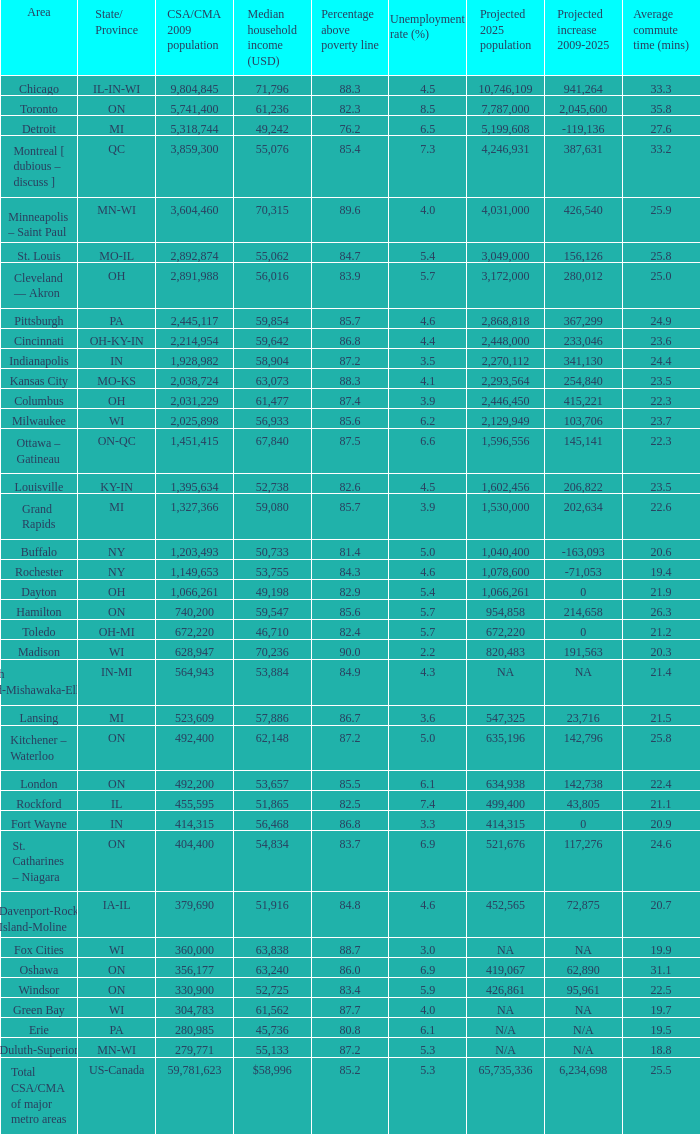What's the CSA/CMA Population in IA-IL? 379690.0. Parse the full table. {'header': ['Area', 'State/ Province', 'CSA/CMA 2009 population', 'Median household income (USD)', 'Percentage above poverty line', 'Unemployment rate (%)', 'Projected 2025 population', 'Projected increase 2009-2025', 'Average commute time (mins)'], 'rows': [['Chicago', 'IL-IN-WI', '9,804,845', '71,796', '88.3', '4.5', '10,746,109', '941,264', '33.3'], ['Toronto', 'ON', '5,741,400', '61,236', '82.3', '8.5', '7,787,000', '2,045,600', '35.8'], ['Detroit', 'MI', '5,318,744', '49,242', '76.2', '6.5', '5,199,608', '-119,136', '27.6'], ['Montreal [ dubious – discuss ]', 'QC', '3,859,300', '55,076', '85.4', '7.3', '4,246,931', '387,631', '33.2'], ['Minneapolis – Saint Paul', 'MN-WI', '3,604,460', '70,315', '89.6', '4.0', '4,031,000', '426,540', '25.9'], ['St. Louis', 'MO-IL', '2,892,874', '55,062', '84.7', '5.4', '3,049,000', '156,126', '25.8'], ['Cleveland — Akron', 'OH', '2,891,988', '56,016', '83.9', '5.7', '3,172,000', '280,012', '25.0'], ['Pittsburgh', 'PA', '2,445,117', '59,854', '85.7', '4.6', '2,868,818', '367,299', '24.9'], ['Cincinnati', 'OH-KY-IN', '2,214,954', '59,642', '86.8', '4.4', '2,448,000', '233,046', '23.6'], ['Indianapolis', 'IN', '1,928,982', '58,904', '87.2', '3.5', '2,270,112', '341,130', '24.4'], ['Kansas City', 'MO-KS', '2,038,724', '63,073', '88.3', '4.1', '2,293,564', '254,840', '23.5'], ['Columbus', 'OH', '2,031,229', '61,477', '87.4', '3.9', '2,446,450', '415,221', '22.3'], ['Milwaukee', 'WI', '2,025,898', '56,933', '85.6', '6.2', '2,129,949', '103,706', '23.7'], ['Ottawa – Gatineau', 'ON-QC', '1,451,415', '67,840', '87.5', '6.6', '1,596,556', '145,141', '22.3'], ['Louisville', 'KY-IN', '1,395,634', '52,738', '82.6', '4.5', '1,602,456', '206,822', '23.5'], ['Grand Rapids', 'MI', '1,327,366', '59,080', '85.7', '3.9', '1,530,000', '202,634', '22.6'], ['Buffalo', 'NY', '1,203,493', '50,733', '81.4', '5.0', '1,040,400', '-163,093', '20.6'], ['Rochester', 'NY', '1,149,653', '53,755', '84.3', '4.6', '1,078,600', '-71,053', '19.4'], ['Dayton', 'OH', '1,066,261', '49,198', '82.9', '5.4', '1,066,261', '0', '21.9'], ['Hamilton', 'ON', '740,200', '59,547', '85.6', '5.7', '954,858', '214,658', '26.3'], ['Toledo', 'OH-MI', '672,220', '46,710', '82.4', '5.7', '672,220', '0', '21.2'], ['Madison', 'WI', '628,947', '70,236', '90.0', '2.2', '820,483', '191,563', '20.3'], ['South Bend-Mishawaka-Elkhart', 'IN-MI', '564,943', '53,884', '84.9', '4.3', 'NA', 'NA', '21.4'], ['Lansing', 'MI', '523,609', '57,886', '86.7', '3.6', '547,325', '23,716', '21.5'], ['Kitchener – Waterloo', 'ON', '492,400', '62,148', '87.2', '5.0', '635,196', '142,796', '25.8'], ['London', 'ON', '492,200', '53,657', '85.5', '6.1', '634,938', '142,738', '22.4'], ['Rockford', 'IL', '455,595', '51,865', '82.5', '7.4', '499,400', '43,805', '21.1'], ['Fort Wayne', 'IN', '414,315', '56,468', '86.8', '3.3', '414,315', '0', '20.9'], ['St. Catharines – Niagara', 'ON', '404,400', '54,834', '83.7', '6.9', '521,676', '117,276', '24.6'], ['Davenport-Rock Island-Moline', 'IA-IL', '379,690', '51,916', '84.8', '4.6', '452,565', '72,875', '20.7'], ['Fox Cities', 'WI', '360,000', '63,838', '88.7', '3.0', 'NA', 'NA', '19.9'], ['Oshawa', 'ON', '356,177', '63,240', '86.0', '6.9', '419,067', '62,890', '31.1'], ['Windsor', 'ON', '330,900', '52,725', '83.4', '5.9', '426,861', '95,961', '22.5'], ['Green Bay', 'WI', '304,783', '61,562', '87.7', '4.0', 'NA', 'NA', '19.7'], ['Erie', 'PA', '280,985', '45,736', '80.8', '6.1', 'N/A', 'N/A', '19.5'], ['Duluth-Superior', 'MN-WI', '279,771', '55,133', '87.2', '5.3', 'N/A', 'N/A', '18.8'], ['Total CSA/CMA of major metro areas', 'US-Canada', '59,781,623', '$58,996', '85.2', '5.3', '65,735,336', '6,234,698', '25.5']]} 